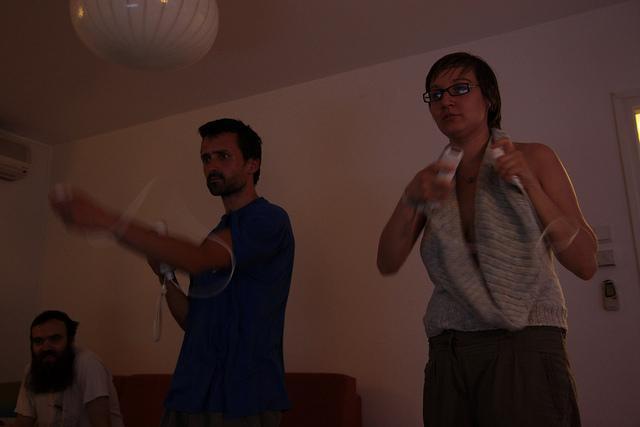How many men are in this picture?
Give a very brief answer. 2. How many light fixtures are in the picture?
Give a very brief answer. 1. How many people are in the photo?
Give a very brief answer. 3. How many men are in the bathroom stall?
Give a very brief answer. 0. How many people are shown?
Give a very brief answer. 3. How many people can you see?
Give a very brief answer. 3. 